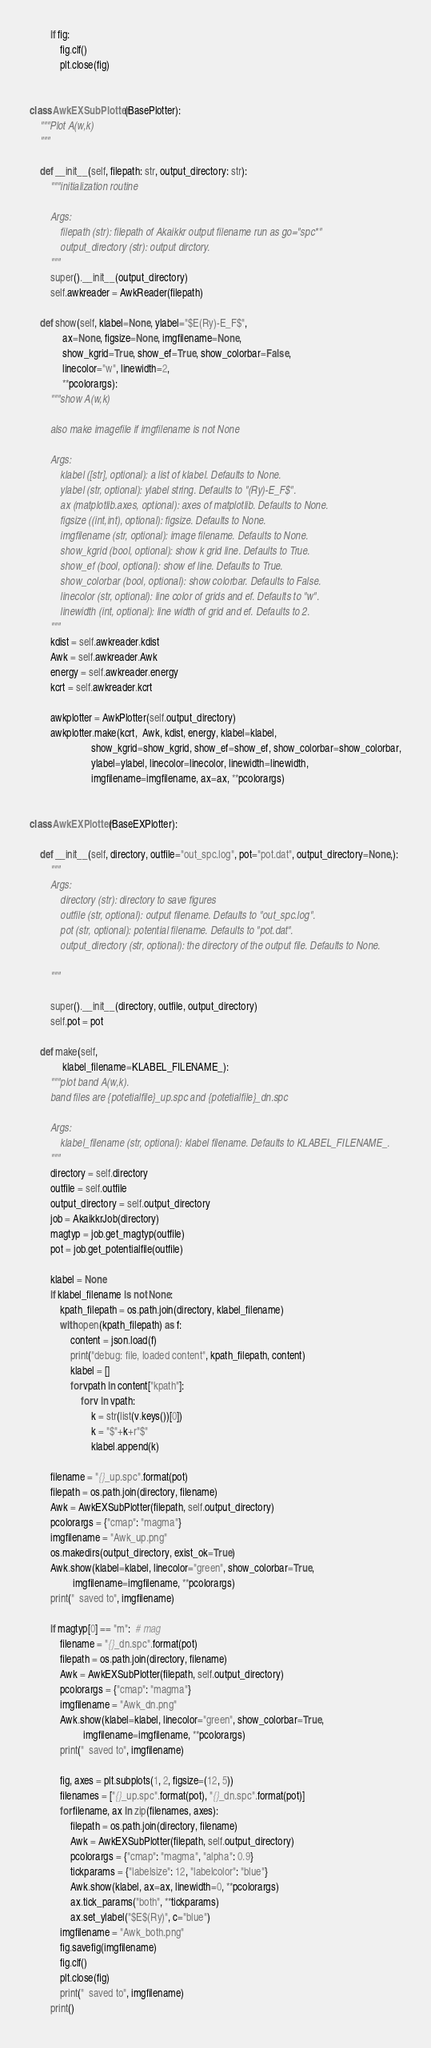Convert code to text. <code><loc_0><loc_0><loc_500><loc_500><_Python_>
        if fig:
            fig.clf()
            plt.close(fig)


class AwkEXSubPlotter(BasePlotter):
    """Plot A(w,k)
    """

    def __init__(self, filepath: str, output_directory: str):
        """initialization routine

        Args:
            filepath (str): filepath of Akaikkr output filename run as go="spc*"
            output_directory (str): output dirctory.
        """
        super().__init__(output_directory)
        self.awkreader = AwkReader(filepath)

    def show(self, klabel=None, ylabel="$E(Ry)-E_F$",
             ax=None, figsize=None, imgfilename=None,
             show_kgrid=True, show_ef=True, show_colorbar=False,
             linecolor="w", linewidth=2,
             **pcolorargs):
        """show A(w,k)

        also make imagefile if imgfilename is not None

        Args:
            klabel ([str], optional): a list of klabel. Defaults to None.
            ylabel (str, optional): ylabel string. Defaults to "(Ry)-E_F$".
            ax (matplotlib.axes, optional): axes of matplotlib. Defaults to None.
            figsize ((int,int), optional): figsize. Defaults to None.
            imgfilename (str, optional): image filename. Defaults to None.
            show_kgrid (bool, optional): show k grid line. Defaults to True.
            show_ef (bool, optional): show ef line. Defaults to True.
            show_colorbar (bool, optional): show colorbar. Defaults to False.
            linecolor (str, optional): line color of grids and ef. Defaults to "w".
            linewidth (int, optional): line width of grid and ef. Defaults to 2.
        """
        kdist = self.awkreader.kdist
        Awk = self.awkreader.Awk
        energy = self.awkreader.energy
        kcrt = self.awkreader.kcrt

        awkplotter = AwkPlotter(self.output_directory)
        awkplotter.make(kcrt,  Awk, kdist, energy, klabel=klabel,
                        show_kgrid=show_kgrid, show_ef=show_ef, show_colorbar=show_colorbar,
                        ylabel=ylabel, linecolor=linecolor, linewidth=linewidth,
                        imgfilename=imgfilename, ax=ax, **pcolorargs)


class AwkEXPlotter(BaseEXPlotter):

    def __init__(self, directory, outfile="out_spc.log", pot="pot.dat", output_directory=None,):
        """
        Args:
            directory (str): directory to save figures
            outfile (str, optional): output filename. Defaults to "out_spc.log".
            pot (str, optional): potential filename. Defaults to "pot.dat".
            output_directory (str, optional): the directory of the output file. Defaults to None.

        """

        super().__init__(directory, outfile, output_directory)
        self.pot = pot

    def make(self,
             klabel_filename=KLABEL_FILENAME_):
        """plot band A(w,k).
        band files are {potetialfile}_up.spc and {potetialfile}_dn.spc

        Args:
            klabel_filename (str, optional): klabel filename. Defaults to KLABEL_FILENAME_.
        """
        directory = self.directory
        outfile = self.outfile
        output_directory = self.output_directory
        job = AkaikkrJob(directory)
        magtyp = job.get_magtyp(outfile)
        pot = job.get_potentialfile(outfile)

        klabel = None
        if klabel_filename is not None:
            kpath_filepath = os.path.join(directory, klabel_filename)
            with open(kpath_filepath) as f:
                content = json.load(f)
                print("debug: file, loaded content", kpath_filepath, content)
                klabel = []
                for vpath in content["kpath"]:
                    for v in vpath:
                        k = str(list(v.keys())[0])
                        k = "$"+k+r"$"
                        klabel.append(k)

        filename = "{}_up.spc".format(pot)
        filepath = os.path.join(directory, filename)
        Awk = AwkEXSubPlotter(filepath, self.output_directory)
        pcolorargs = {"cmap": "magma"}
        imgfilename = "Awk_up.png"
        os.makedirs(output_directory, exist_ok=True)
        Awk.show(klabel=klabel, linecolor="green", show_colorbar=True,
                 imgfilename=imgfilename, **pcolorargs)
        print("  saved to", imgfilename)

        if magtyp[0] == "m":  # mag
            filename = "{}_dn.spc".format(pot)
            filepath = os.path.join(directory, filename)
            Awk = AwkEXSubPlotter(filepath, self.output_directory)
            pcolorargs = {"cmap": "magma"}
            imgfilename = "Awk_dn.png"
            Awk.show(klabel=klabel, linecolor="green", show_colorbar=True,
                     imgfilename=imgfilename, **pcolorargs)
            print("  saved to", imgfilename)

            fig, axes = plt.subplots(1, 2, figsize=(12, 5))
            filenames = ["{}_up.spc".format(pot), "{}_dn.spc".format(pot)]
            for filename, ax in zip(filenames, axes):
                filepath = os.path.join(directory, filename)
                Awk = AwkEXSubPlotter(filepath, self.output_directory)
                pcolorargs = {"cmap": "magma", "alpha": 0.9}
                tickparams = {"labelsize": 12, "labelcolor": "blue"}
                Awk.show(klabel, ax=ax, linewidth=0, **pcolorargs)
                ax.tick_params("both", **tickparams)
                ax.set_ylabel("$E$(Ry)", c="blue")
            imgfilename = "Awk_both.png"
            fig.savefig(imgfilename)
            fig.clf()
            plt.close(fig)
            print("  saved to", imgfilename)
        print()
</code> 